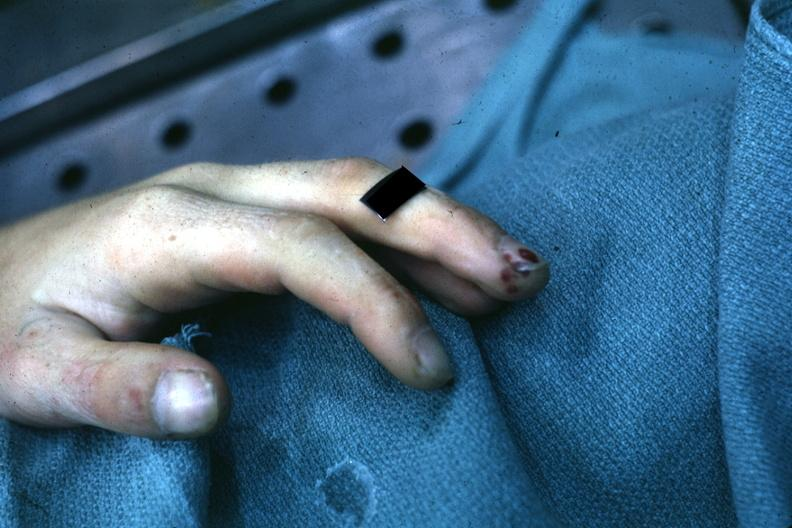s hand present?
Answer the question using a single word or phrase. Yes 